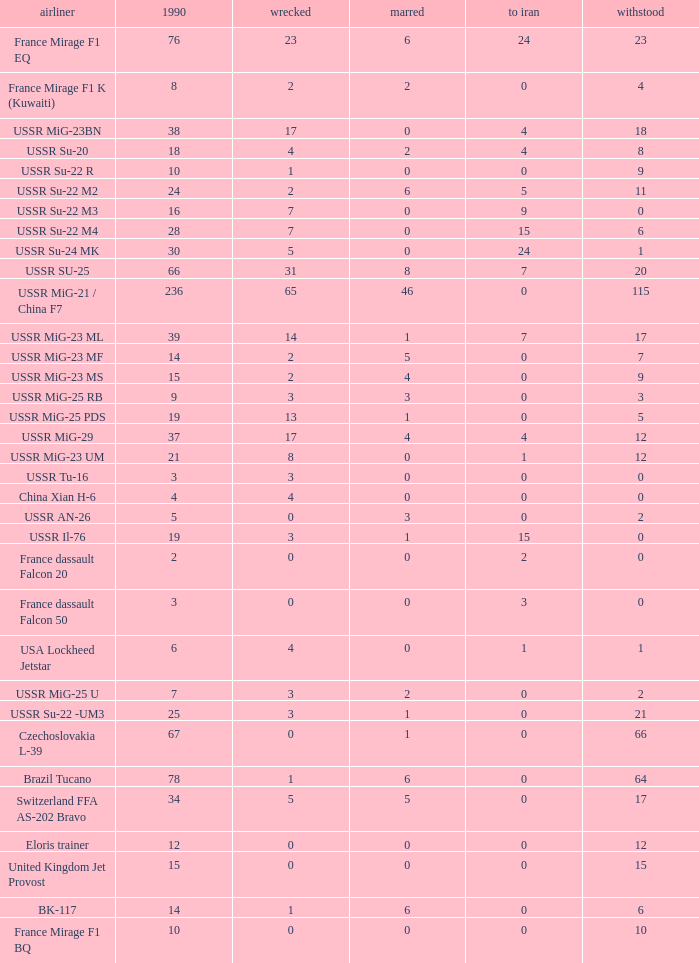If there were 14 in 1990 and 6 survived how many were destroyed? 1.0. 